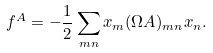Convert formula to latex. <formula><loc_0><loc_0><loc_500><loc_500>f ^ { A } = - \frac { 1 } { 2 } \sum _ { m n } x _ { m } ( { \Omega A } ) _ { m n } x _ { n } .</formula> 